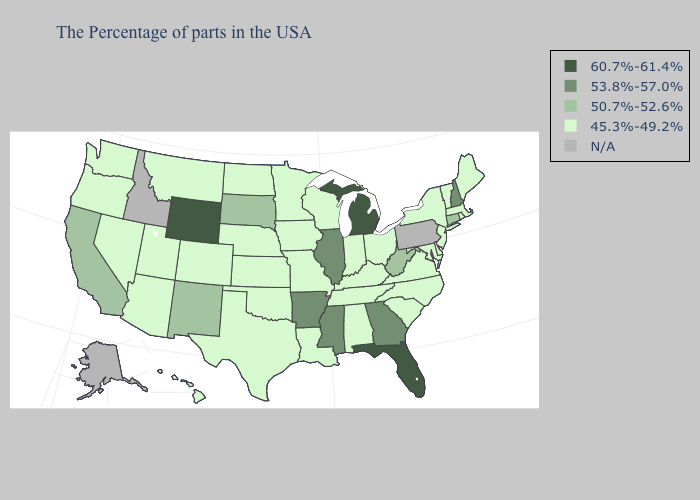Among the states that border Kansas , which have the lowest value?
Answer briefly. Missouri, Nebraska, Oklahoma, Colorado. Which states have the lowest value in the USA?
Give a very brief answer. Maine, Massachusetts, Rhode Island, Vermont, New York, New Jersey, Delaware, Maryland, Virginia, North Carolina, South Carolina, Ohio, Kentucky, Indiana, Alabama, Tennessee, Wisconsin, Louisiana, Missouri, Minnesota, Iowa, Kansas, Nebraska, Oklahoma, Texas, North Dakota, Colorado, Utah, Montana, Arizona, Nevada, Washington, Oregon, Hawaii. Among the states that border Wyoming , which have the lowest value?
Quick response, please. Nebraska, Colorado, Utah, Montana. Name the states that have a value in the range 53.8%-57.0%?
Short answer required. New Hampshire, Georgia, Illinois, Mississippi, Arkansas. What is the lowest value in the USA?
Quick response, please. 45.3%-49.2%. Does Kansas have the lowest value in the MidWest?
Keep it brief. Yes. How many symbols are there in the legend?
Write a very short answer. 5. Name the states that have a value in the range 50.7%-52.6%?
Short answer required. Connecticut, West Virginia, South Dakota, New Mexico, California. What is the value of Louisiana?
Write a very short answer. 45.3%-49.2%. Which states have the highest value in the USA?
Quick response, please. Florida, Michigan, Wyoming. Among the states that border South Dakota , which have the highest value?
Write a very short answer. Wyoming. What is the value of Indiana?
Write a very short answer. 45.3%-49.2%. Is the legend a continuous bar?
Quick response, please. No. What is the value of New Jersey?
Short answer required. 45.3%-49.2%. What is the value of Kansas?
Answer briefly. 45.3%-49.2%. 